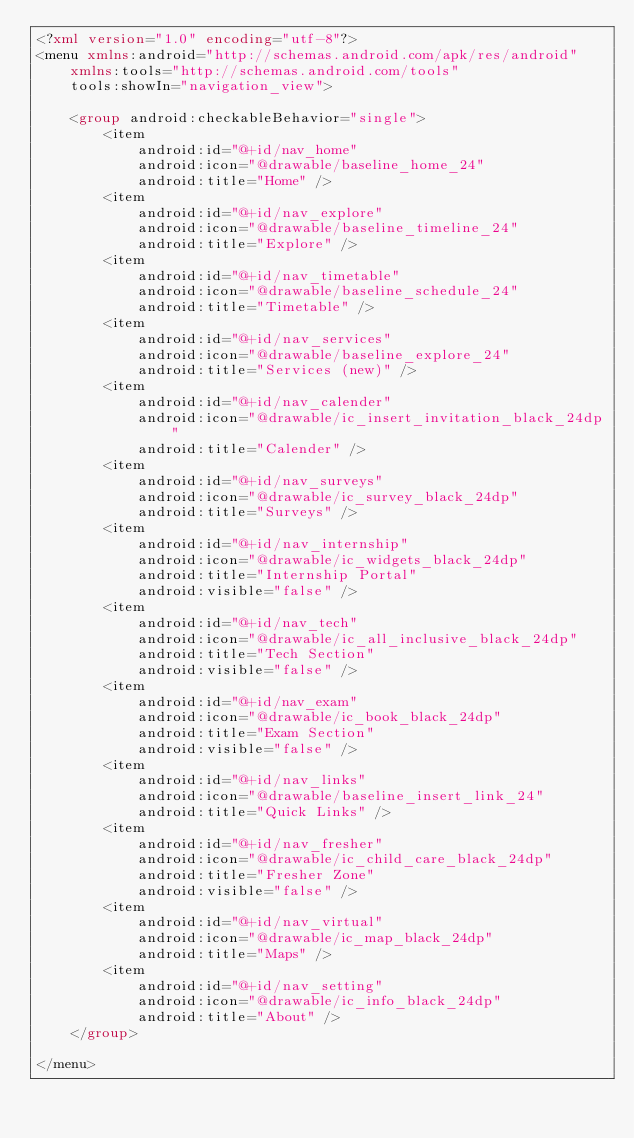Convert code to text. <code><loc_0><loc_0><loc_500><loc_500><_XML_><?xml version="1.0" encoding="utf-8"?>
<menu xmlns:android="http://schemas.android.com/apk/res/android"
    xmlns:tools="http://schemas.android.com/tools"
    tools:showIn="navigation_view">

    <group android:checkableBehavior="single">
        <item
            android:id="@+id/nav_home"
            android:icon="@drawable/baseline_home_24"
            android:title="Home" />
        <item
            android:id="@+id/nav_explore"
            android:icon="@drawable/baseline_timeline_24"
            android:title="Explore" />
        <item
            android:id="@+id/nav_timetable"
            android:icon="@drawable/baseline_schedule_24"
            android:title="Timetable" />
        <item
            android:id="@+id/nav_services"
            android:icon="@drawable/baseline_explore_24"
            android:title="Services (new)" />
        <item
            android:id="@+id/nav_calender"
            android:icon="@drawable/ic_insert_invitation_black_24dp"
            android:title="Calender" />
        <item
            android:id="@+id/nav_surveys"
            android:icon="@drawable/ic_survey_black_24dp"
            android:title="Surveys" />
        <item
            android:id="@+id/nav_internship"
            android:icon="@drawable/ic_widgets_black_24dp"
            android:title="Internship Portal"
            android:visible="false" />
        <item
            android:id="@+id/nav_tech"
            android:icon="@drawable/ic_all_inclusive_black_24dp"
            android:title="Tech Section"
            android:visible="false" />
        <item
            android:id="@+id/nav_exam"
            android:icon="@drawable/ic_book_black_24dp"
            android:title="Exam Section"
            android:visible="false" />
        <item
            android:id="@+id/nav_links"
            android:icon="@drawable/baseline_insert_link_24"
            android:title="Quick Links" />
        <item
            android:id="@+id/nav_fresher"
            android:icon="@drawable/ic_child_care_black_24dp"
            android:title="Fresher Zone"
            android:visible="false" />
        <item
            android:id="@+id/nav_virtual"
            android:icon="@drawable/ic_map_black_24dp"
            android:title="Maps" />
        <item
            android:id="@+id/nav_setting"
            android:icon="@drawable/ic_info_black_24dp"
            android:title="About" />
    </group>

</menu>
</code> 